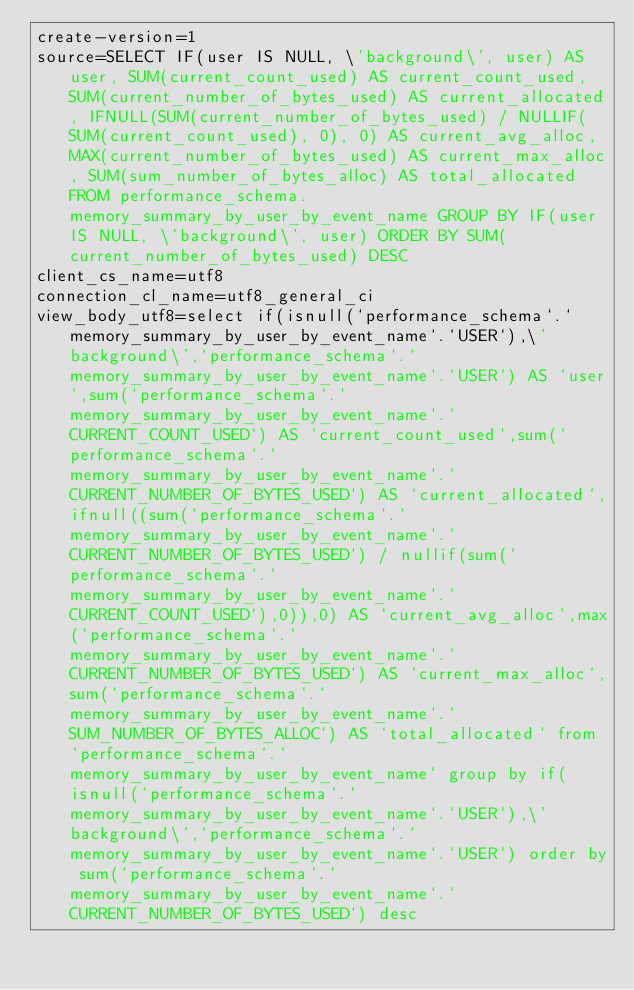<code> <loc_0><loc_0><loc_500><loc_500><_VisualBasic_>create-version=1
source=SELECT IF(user IS NULL, \'background\', user) AS user, SUM(current_count_used) AS current_count_used, SUM(current_number_of_bytes_used) AS current_allocated, IFNULL(SUM(current_number_of_bytes_used) / NULLIF(SUM(current_count_used), 0), 0) AS current_avg_alloc, MAX(current_number_of_bytes_used) AS current_max_alloc, SUM(sum_number_of_bytes_alloc) AS total_allocated FROM performance_schema.memory_summary_by_user_by_event_name GROUP BY IF(user IS NULL, \'background\', user) ORDER BY SUM(current_number_of_bytes_used) DESC
client_cs_name=utf8
connection_cl_name=utf8_general_ci
view_body_utf8=select if(isnull(`performance_schema`.`memory_summary_by_user_by_event_name`.`USER`),\'background\',`performance_schema`.`memory_summary_by_user_by_event_name`.`USER`) AS `user`,sum(`performance_schema`.`memory_summary_by_user_by_event_name`.`CURRENT_COUNT_USED`) AS `current_count_used`,sum(`performance_schema`.`memory_summary_by_user_by_event_name`.`CURRENT_NUMBER_OF_BYTES_USED`) AS `current_allocated`,ifnull((sum(`performance_schema`.`memory_summary_by_user_by_event_name`.`CURRENT_NUMBER_OF_BYTES_USED`) / nullif(sum(`performance_schema`.`memory_summary_by_user_by_event_name`.`CURRENT_COUNT_USED`),0)),0) AS `current_avg_alloc`,max(`performance_schema`.`memory_summary_by_user_by_event_name`.`CURRENT_NUMBER_OF_BYTES_USED`) AS `current_max_alloc`,sum(`performance_schema`.`memory_summary_by_user_by_event_name`.`SUM_NUMBER_OF_BYTES_ALLOC`) AS `total_allocated` from `performance_schema`.`memory_summary_by_user_by_event_name` group by if(isnull(`performance_schema`.`memory_summary_by_user_by_event_name`.`USER`),\'background\',`performance_schema`.`memory_summary_by_user_by_event_name`.`USER`) order by sum(`performance_schema`.`memory_summary_by_user_by_event_name`.`CURRENT_NUMBER_OF_BYTES_USED`) desc
</code> 